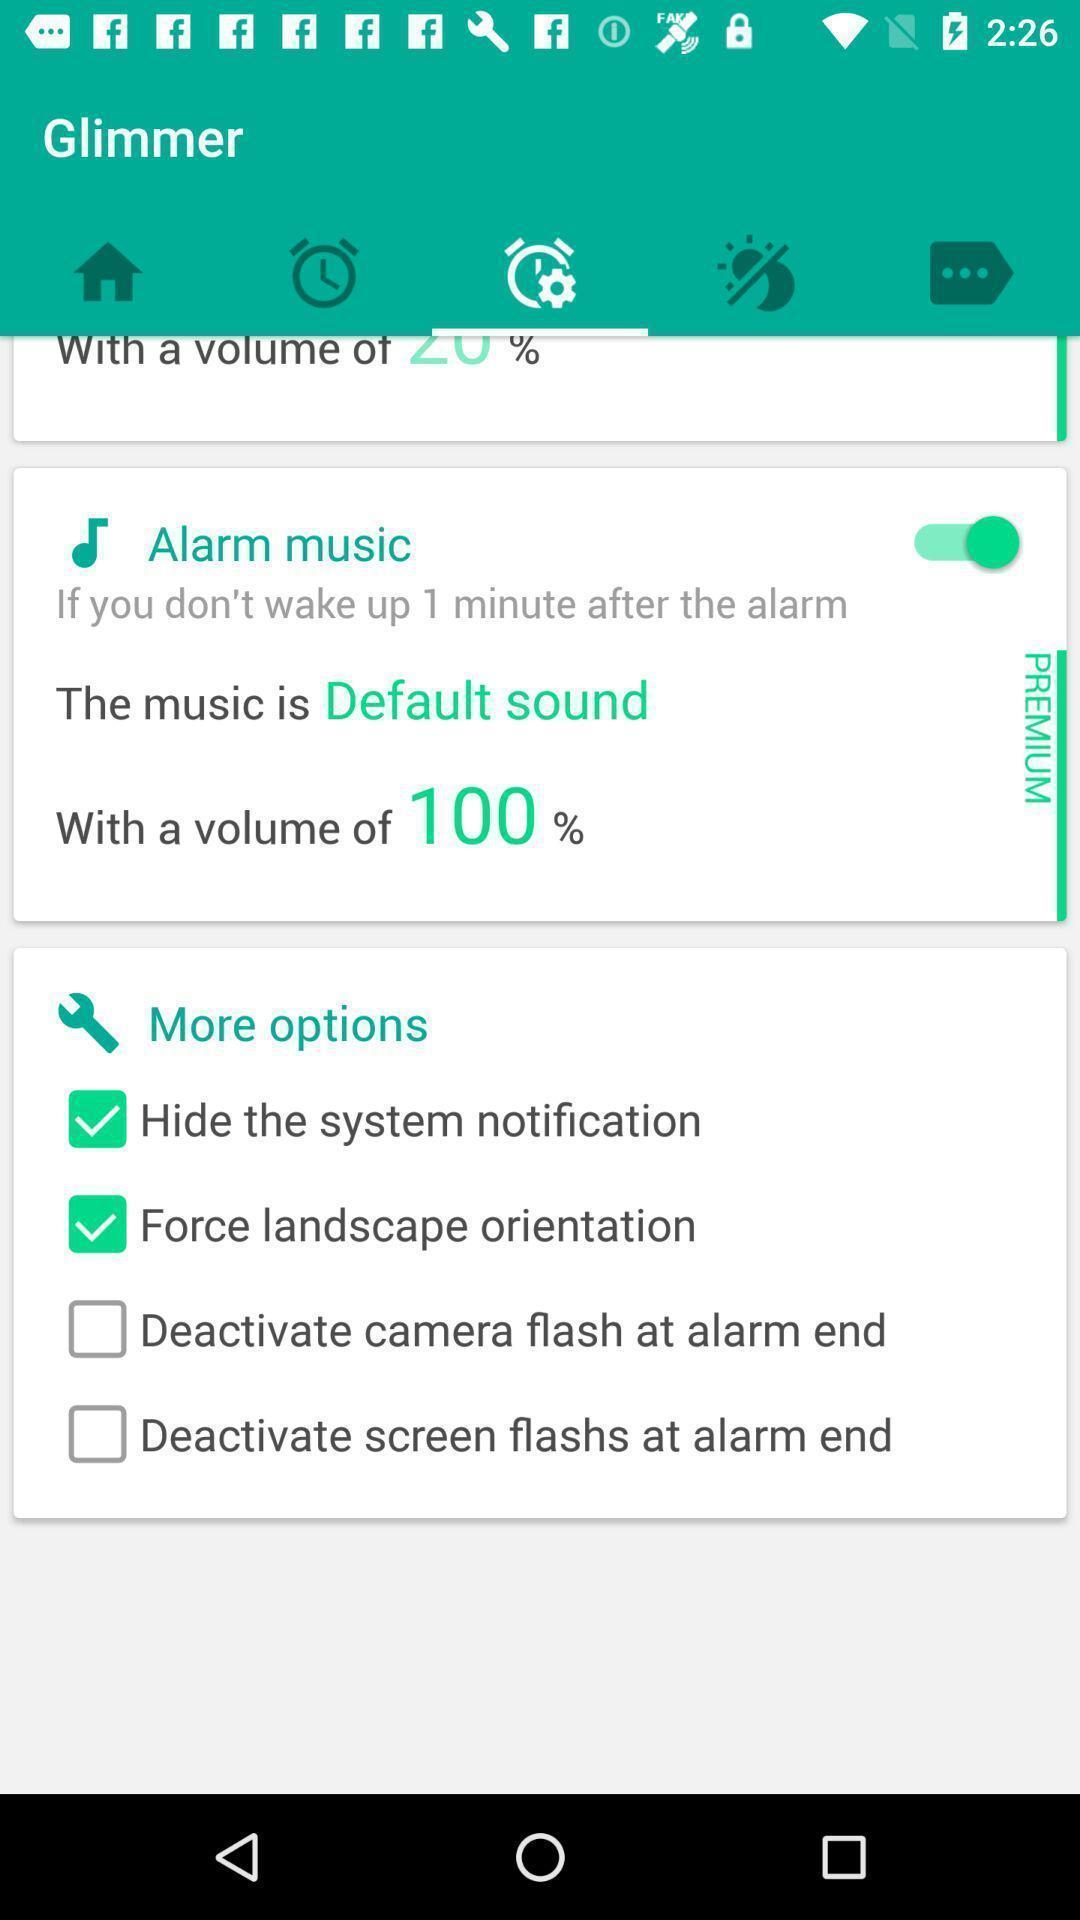Provide a description of this screenshot. Screen showing alarm with more options. 